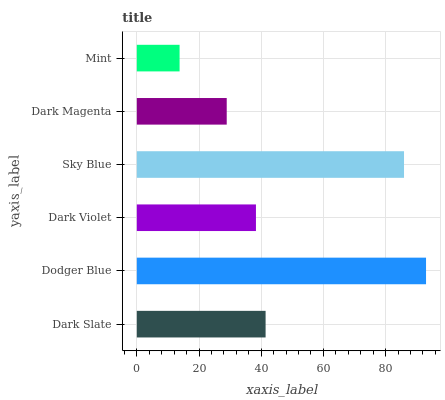Is Mint the minimum?
Answer yes or no. Yes. Is Dodger Blue the maximum?
Answer yes or no. Yes. Is Dark Violet the minimum?
Answer yes or no. No. Is Dark Violet the maximum?
Answer yes or no. No. Is Dodger Blue greater than Dark Violet?
Answer yes or no. Yes. Is Dark Violet less than Dodger Blue?
Answer yes or no. Yes. Is Dark Violet greater than Dodger Blue?
Answer yes or no. No. Is Dodger Blue less than Dark Violet?
Answer yes or no. No. Is Dark Slate the high median?
Answer yes or no. Yes. Is Dark Violet the low median?
Answer yes or no. Yes. Is Dark Violet the high median?
Answer yes or no. No. Is Mint the low median?
Answer yes or no. No. 